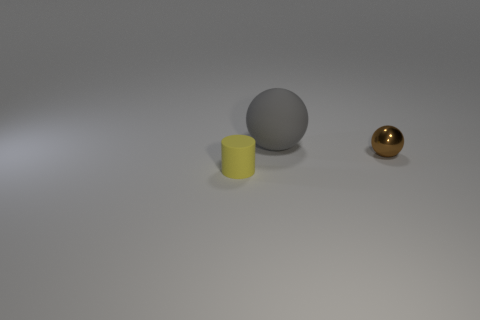Add 3 red shiny cubes. How many objects exist? 6 Subtract all cylinders. How many objects are left? 2 Subtract all blue rubber objects. Subtract all small things. How many objects are left? 1 Add 1 yellow rubber cylinders. How many yellow rubber cylinders are left? 2 Add 2 gray rubber cylinders. How many gray rubber cylinders exist? 2 Subtract 0 purple cylinders. How many objects are left? 3 